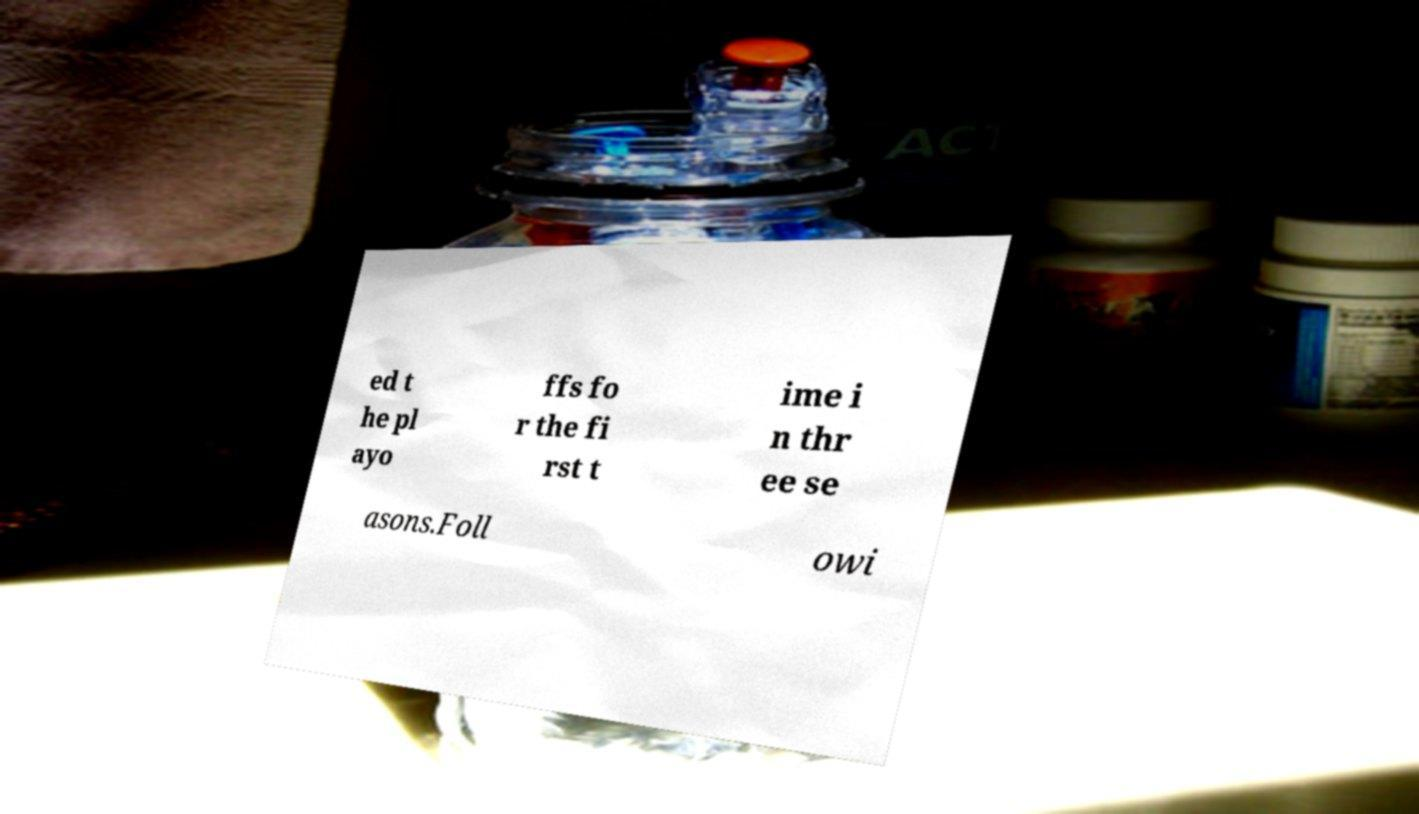Please identify and transcribe the text found in this image. ed t he pl ayo ffs fo r the fi rst t ime i n thr ee se asons.Foll owi 